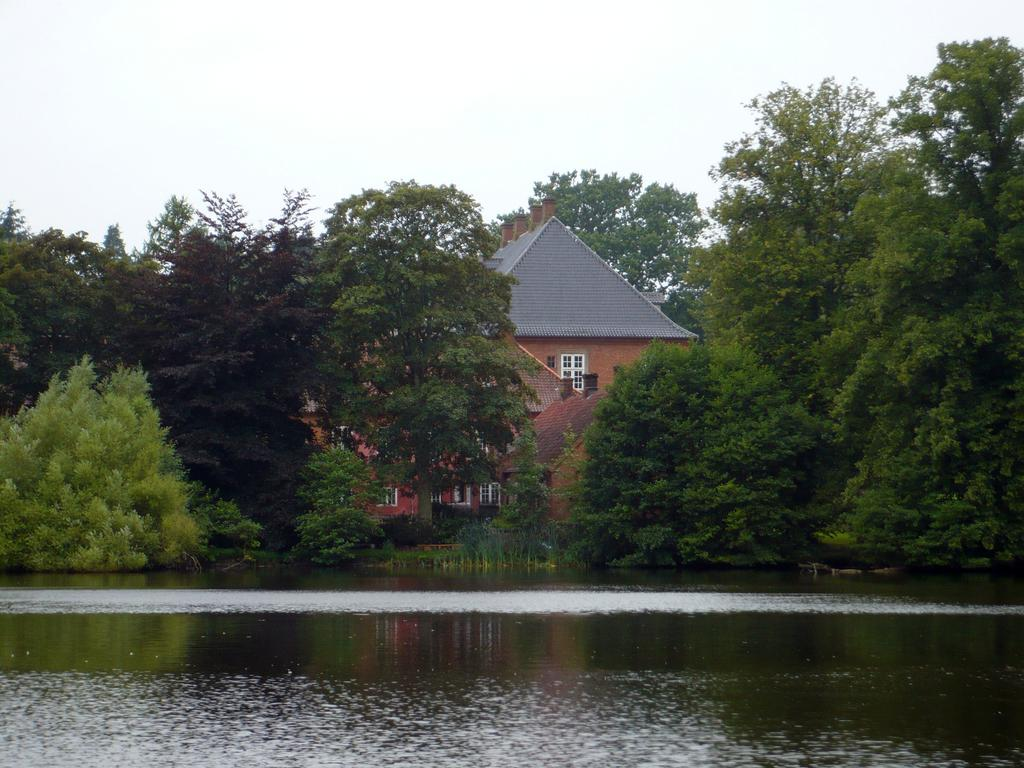What type of natural feature is present in the image? There is a river in the image. What other objects or features can be seen in the image? There are trees and a house in the image. What is visible in the background of the image? The sky is visible in the image. How many beds are visible in the image? There are no beds present in the image. What type of farm can be seen in the image? There is no farm present in the image. 